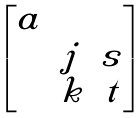<formula> <loc_0><loc_0><loc_500><loc_500>\begin{bmatrix} a & & \\ & j & s \\ & k & t \end{bmatrix}</formula> 